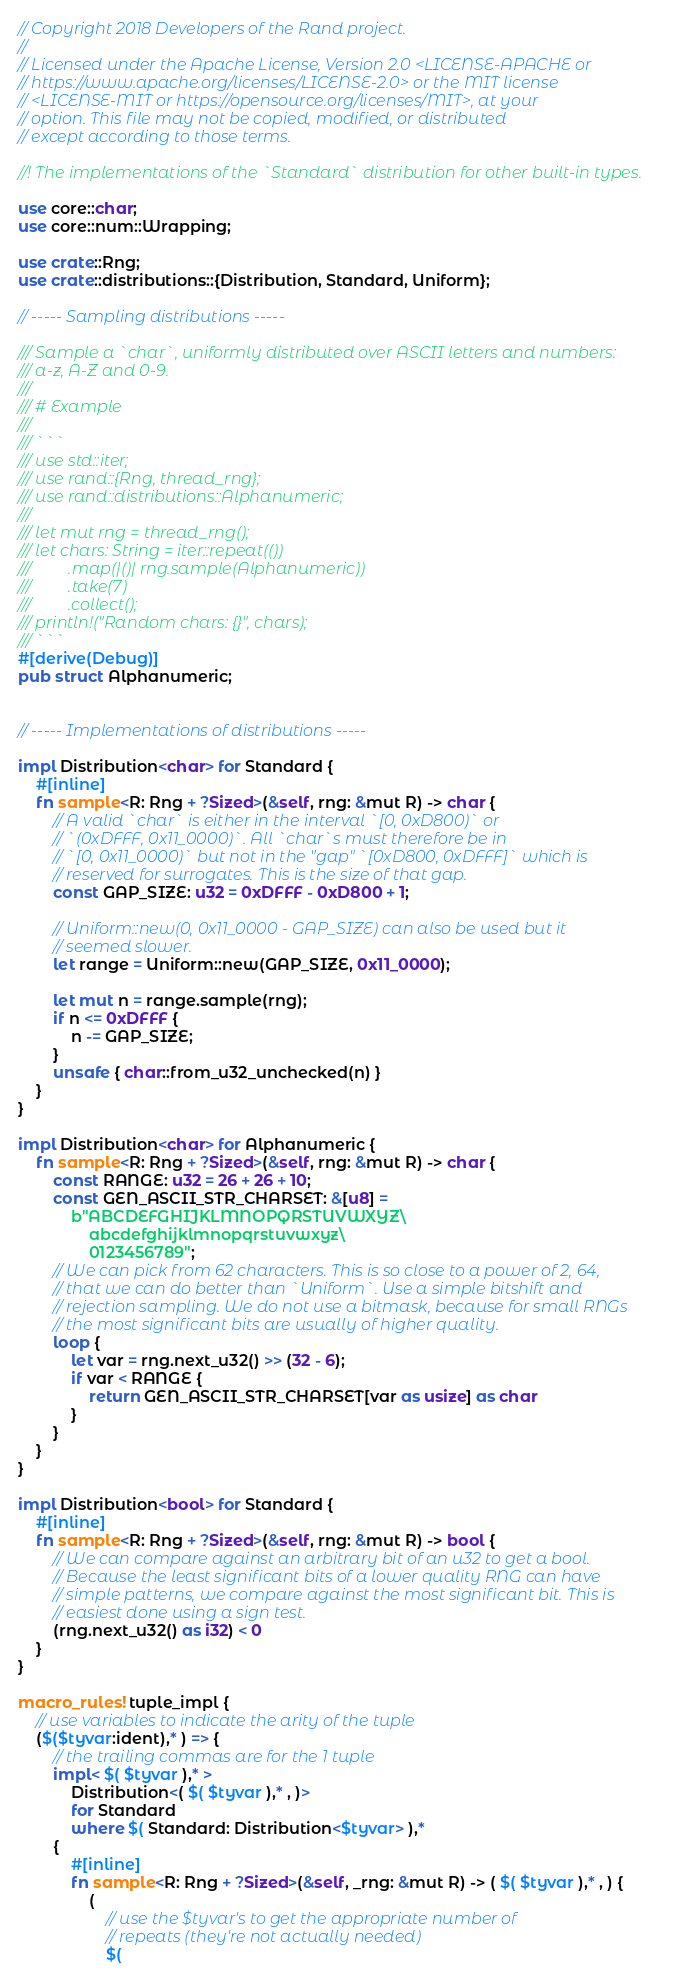Convert code to text. <code><loc_0><loc_0><loc_500><loc_500><_Rust_>// Copyright 2018 Developers of the Rand project.
//
// Licensed under the Apache License, Version 2.0 <LICENSE-APACHE or
// https://www.apache.org/licenses/LICENSE-2.0> or the MIT license
// <LICENSE-MIT or https://opensource.org/licenses/MIT>, at your
// option. This file may not be copied, modified, or distributed
// except according to those terms.

//! The implementations of the `Standard` distribution for other built-in types.

use core::char;
use core::num::Wrapping;

use crate::Rng;
use crate::distributions::{Distribution, Standard, Uniform};

// ----- Sampling distributions -----

/// Sample a `char`, uniformly distributed over ASCII letters and numbers:
/// a-z, A-Z and 0-9.
/// 
/// # Example
///
/// ```
/// use std::iter;
/// use rand::{Rng, thread_rng};
/// use rand::distributions::Alphanumeric;
/// 
/// let mut rng = thread_rng();
/// let chars: String = iter::repeat(())
///         .map(|()| rng.sample(Alphanumeric))
///         .take(7)
///         .collect();
/// println!("Random chars: {}", chars);
/// ```
#[derive(Debug)]
pub struct Alphanumeric;


// ----- Implementations of distributions -----

impl Distribution<char> for Standard {
    #[inline]
    fn sample<R: Rng + ?Sized>(&self, rng: &mut R) -> char {
        // A valid `char` is either in the interval `[0, 0xD800)` or
        // `(0xDFFF, 0x11_0000)`. All `char`s must therefore be in
        // `[0, 0x11_0000)` but not in the "gap" `[0xD800, 0xDFFF]` which is
        // reserved for surrogates. This is the size of that gap.
        const GAP_SIZE: u32 = 0xDFFF - 0xD800 + 1;

        // Uniform::new(0, 0x11_0000 - GAP_SIZE) can also be used but it
        // seemed slower.
        let range = Uniform::new(GAP_SIZE, 0x11_0000);

        let mut n = range.sample(rng);
        if n <= 0xDFFF {
            n -= GAP_SIZE;
        }
        unsafe { char::from_u32_unchecked(n) }
    }
}

impl Distribution<char> for Alphanumeric {
    fn sample<R: Rng + ?Sized>(&self, rng: &mut R) -> char {
        const RANGE: u32 = 26 + 26 + 10;
        const GEN_ASCII_STR_CHARSET: &[u8] =
            b"ABCDEFGHIJKLMNOPQRSTUVWXYZ\
                abcdefghijklmnopqrstuvwxyz\
                0123456789";
        // We can pick from 62 characters. This is so close to a power of 2, 64,
        // that we can do better than `Uniform`. Use a simple bitshift and
        // rejection sampling. We do not use a bitmask, because for small RNGs
        // the most significant bits are usually of higher quality.
        loop {
            let var = rng.next_u32() >> (32 - 6);
            if var < RANGE {
                return GEN_ASCII_STR_CHARSET[var as usize] as char
            }
        }
    }
}

impl Distribution<bool> for Standard {
    #[inline]
    fn sample<R: Rng + ?Sized>(&self, rng: &mut R) -> bool {
        // We can compare against an arbitrary bit of an u32 to get a bool.
        // Because the least significant bits of a lower quality RNG can have
        // simple patterns, we compare against the most significant bit. This is
        // easiest done using a sign test.
        (rng.next_u32() as i32) < 0
    }
}

macro_rules! tuple_impl {
    // use variables to indicate the arity of the tuple
    ($($tyvar:ident),* ) => {
        // the trailing commas are for the 1 tuple
        impl< $( $tyvar ),* >
            Distribution<( $( $tyvar ),* , )>
            for Standard
            where $( Standard: Distribution<$tyvar> ),*
        {
            #[inline]
            fn sample<R: Rng + ?Sized>(&self, _rng: &mut R) -> ( $( $tyvar ),* , ) {
                (
                    // use the $tyvar's to get the appropriate number of
                    // repeats (they're not actually needed)
                    $(</code> 